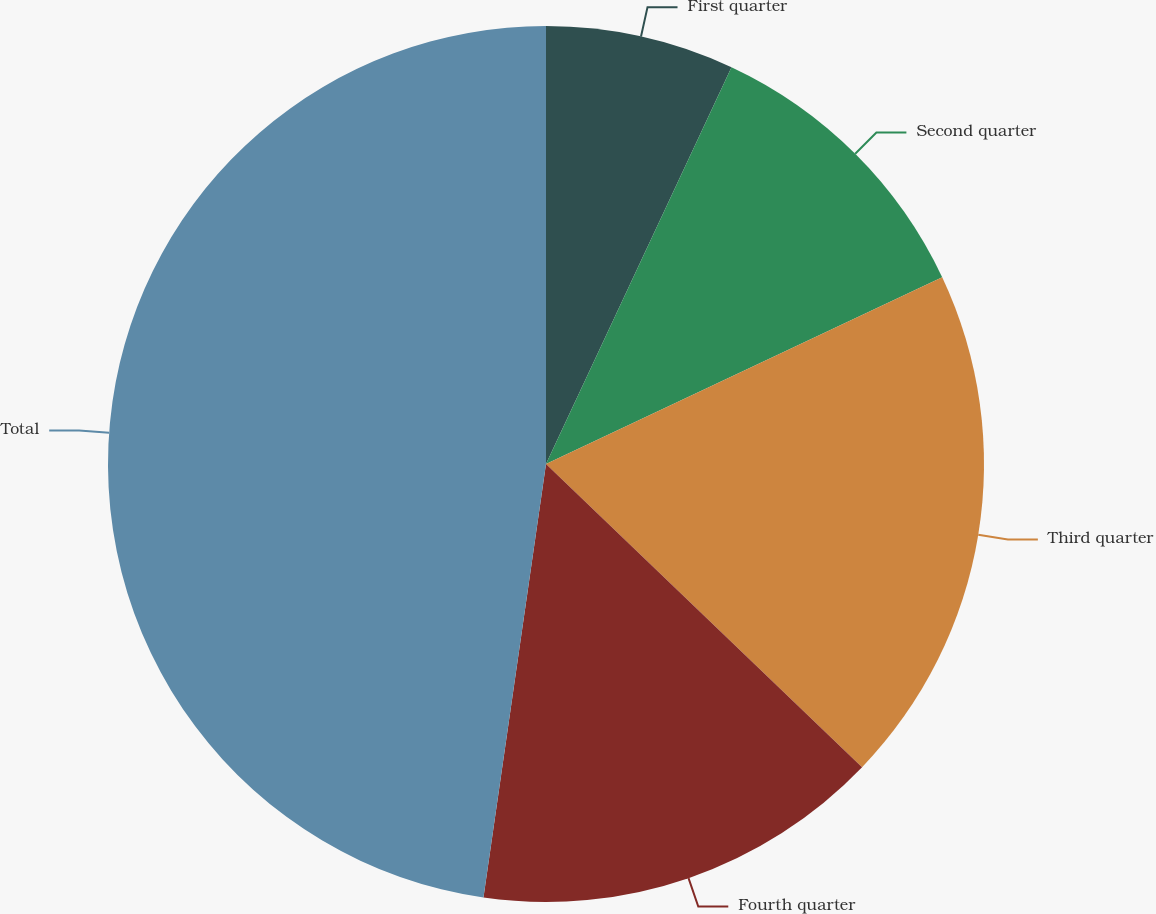Convert chart. <chart><loc_0><loc_0><loc_500><loc_500><pie_chart><fcel>First quarter<fcel>Second quarter<fcel>Third quarter<fcel>Fourth quarter<fcel>Total<nl><fcel>6.96%<fcel>11.03%<fcel>19.18%<fcel>15.11%<fcel>47.72%<nl></chart> 